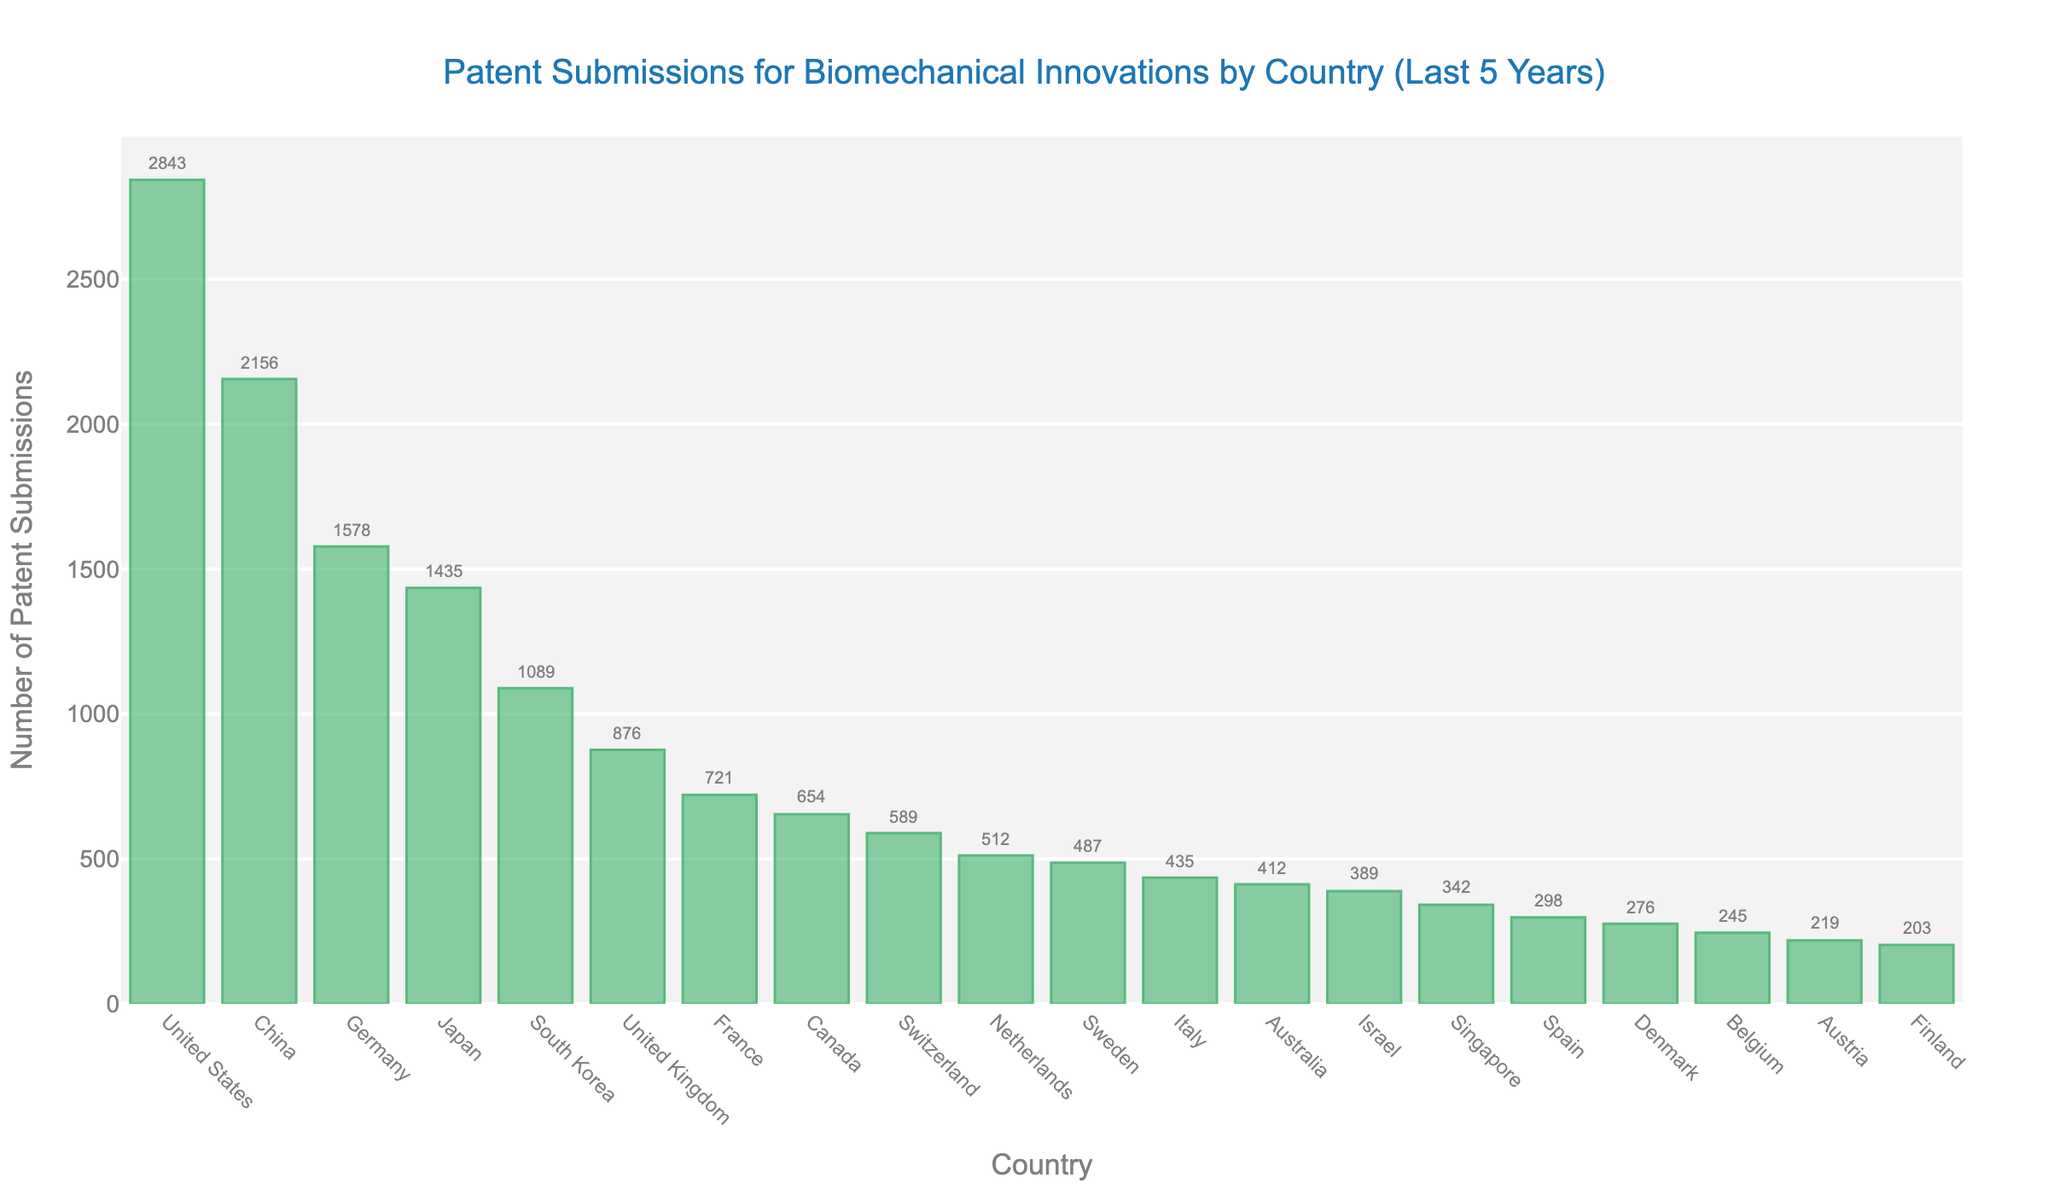What's the country with the highest number of patent submissions? The country with the highest bar on the chart represents the highest number of patent submissions. The bar for the United States is the tallest.
Answer: United States Which country has the second highest number of patent submissions? The country with the second tallest bar represents the second highest number of patent submissions. The bar for China is slightly shorter than the United States but taller than the rest.
Answer: China How many more patents did the United States submit compared to Germany? Look at the height of the bar for the United States (2843) and subtract the height of the bar for Germany (1578). The difference is 2843 - 1578.
Answer: 1265 Compare the total number of patent submissions between Japan and South Korea. Which country submitted more patents? Compare the heights of the bars for Japan (1435) and South Korea (1089). Japan’s bar is taller.
Answer: Japan What is the combined number of patent submissions for the United Kingdom, France, and Canada? Add the number of patent submissions from the bars of the United Kingdom (876), France (721), and Canada (654). The sum is 876 + 721 + 654.
Answer: 2251 Which country has fewer patent submissions, Israel or Singapore? Compare the heights of the bars for Israel (389) and Singapore (342). The bar for Singapore is shorter.
Answer: Singapore What is the approximate difference in patent submissions between Australia and Italy? Subtract the number of patent submissions for Italy (435) from Australia (412). The difference is 435 - 412.
Answer: 23 How many countries submitted more than 1000 patents in the last 5 years? Count the number of bars that are taller than 1000. These bars represent the countries: United States, China, Germany, Japan, and South Korea.
Answer: 5 Which country represents the median value in patent submissions when the countries are ranked in descending order? There are 20 countries, so the median will be the 10th value when sorted in descending order. The median country is the Netherlands, with 512 patent submissions.
Answer: Netherlands 